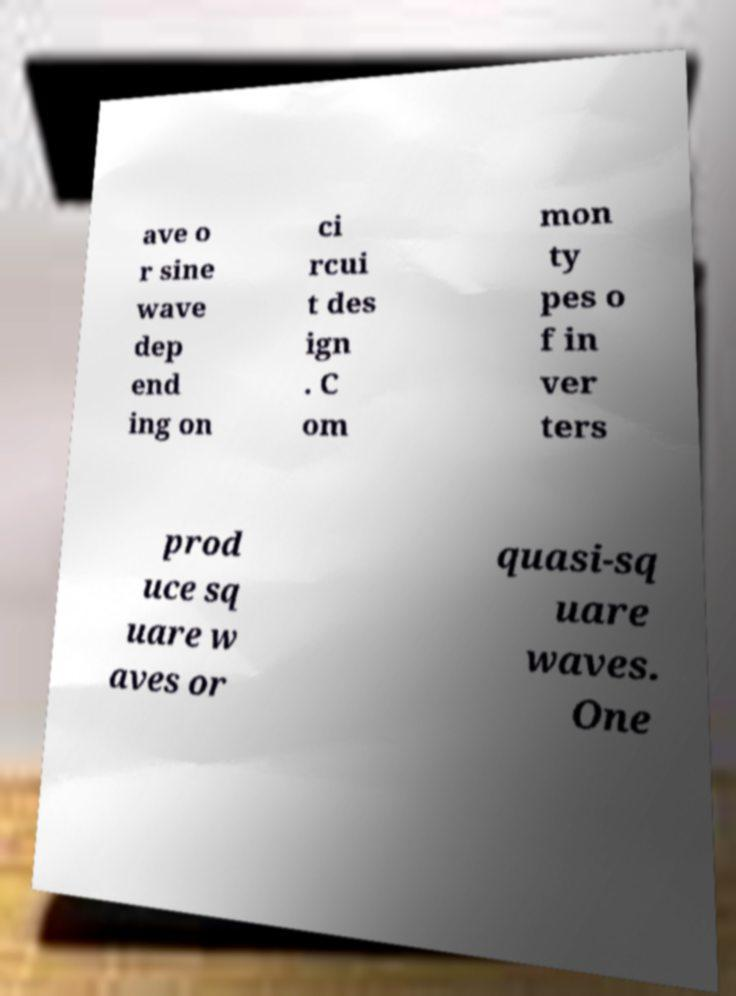Can you read and provide the text displayed in the image?This photo seems to have some interesting text. Can you extract and type it out for me? ave o r sine wave dep end ing on ci rcui t des ign . C om mon ty pes o f in ver ters prod uce sq uare w aves or quasi-sq uare waves. One 